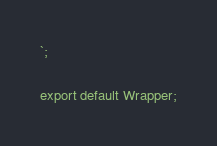<code> <loc_0><loc_0><loc_500><loc_500><_JavaScript_>`;

export default Wrapper;
</code> 